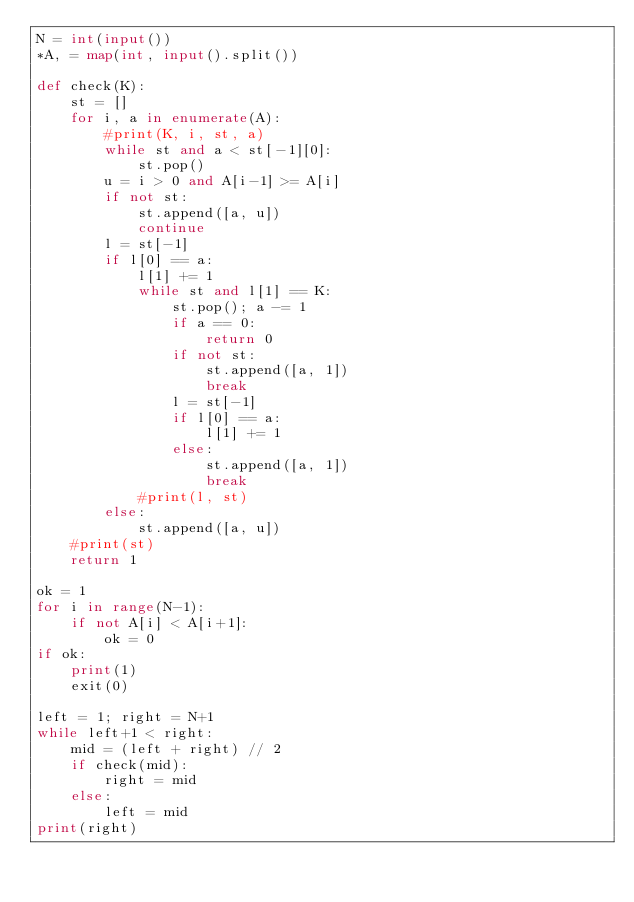<code> <loc_0><loc_0><loc_500><loc_500><_Python_>N = int(input())
*A, = map(int, input().split())

def check(K):
    st = []
    for i, a in enumerate(A):
        #print(K, i, st, a)
        while st and a < st[-1][0]:
            st.pop()
        u = i > 0 and A[i-1] >= A[i]
        if not st:
            st.append([a, u])
            continue
        l = st[-1]
        if l[0] == a:
            l[1] += 1
            while st and l[1] == K:
                st.pop(); a -= 1
                if a == 0:
                    return 0
                if not st:
                    st.append([a, 1])
                    break
                l = st[-1]
                if l[0] == a:
                    l[1] += 1
                else:
                    st.append([a, 1])
                    break
            #print(l, st)
        else:
            st.append([a, u])
    #print(st)
    return 1

ok = 1
for i in range(N-1):
    if not A[i] < A[i+1]:
        ok = 0
if ok:
    print(1)
    exit(0)

left = 1; right = N+1
while left+1 < right:
    mid = (left + right) // 2
    if check(mid):
        right = mid
    else:
        left = mid
print(right)</code> 